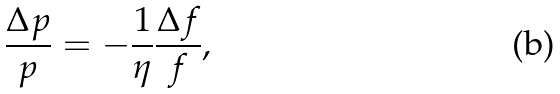<formula> <loc_0><loc_0><loc_500><loc_500>\frac { \Delta p } { p } = - \frac { 1 } { \eta } \frac { \Delta f } { f } ,</formula> 